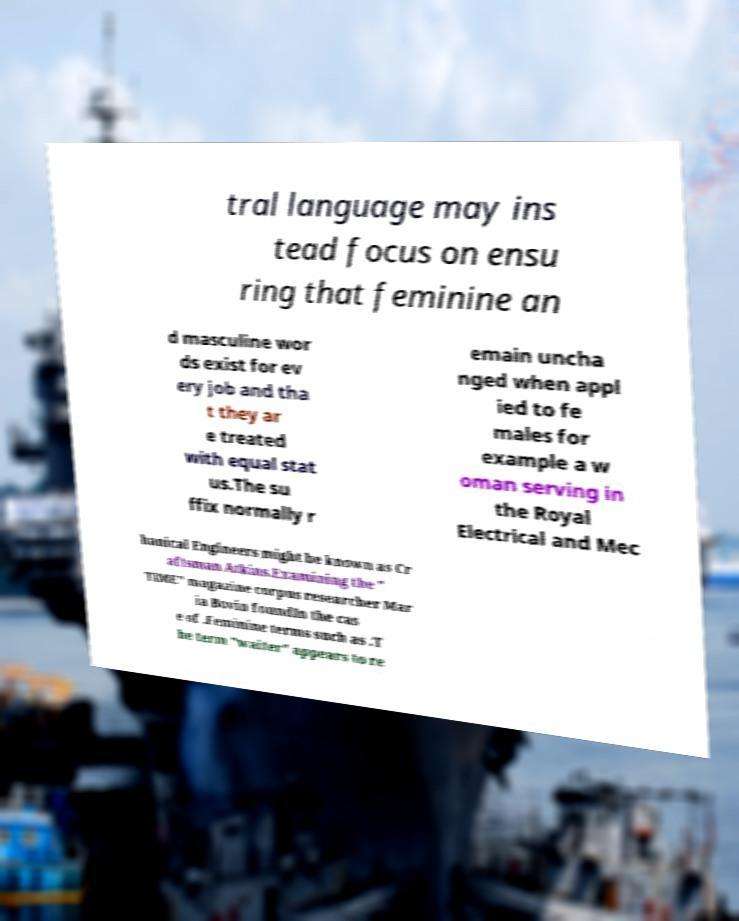Can you accurately transcribe the text from the provided image for me? tral language may ins tead focus on ensu ring that feminine an d masculine wor ds exist for ev ery job and tha t they ar e treated with equal stat us.The su ffix normally r emain uncha nged when appl ied to fe males for example a w oman serving in the Royal Electrical and Mec hanical Engineers might be known as Cr aftsman Atkins.Examining the " TIME" magazine corpus researcher Mar ia Bovin foundIn the cas e of .Feminine terms such as .T he term "waiter" appears to re 